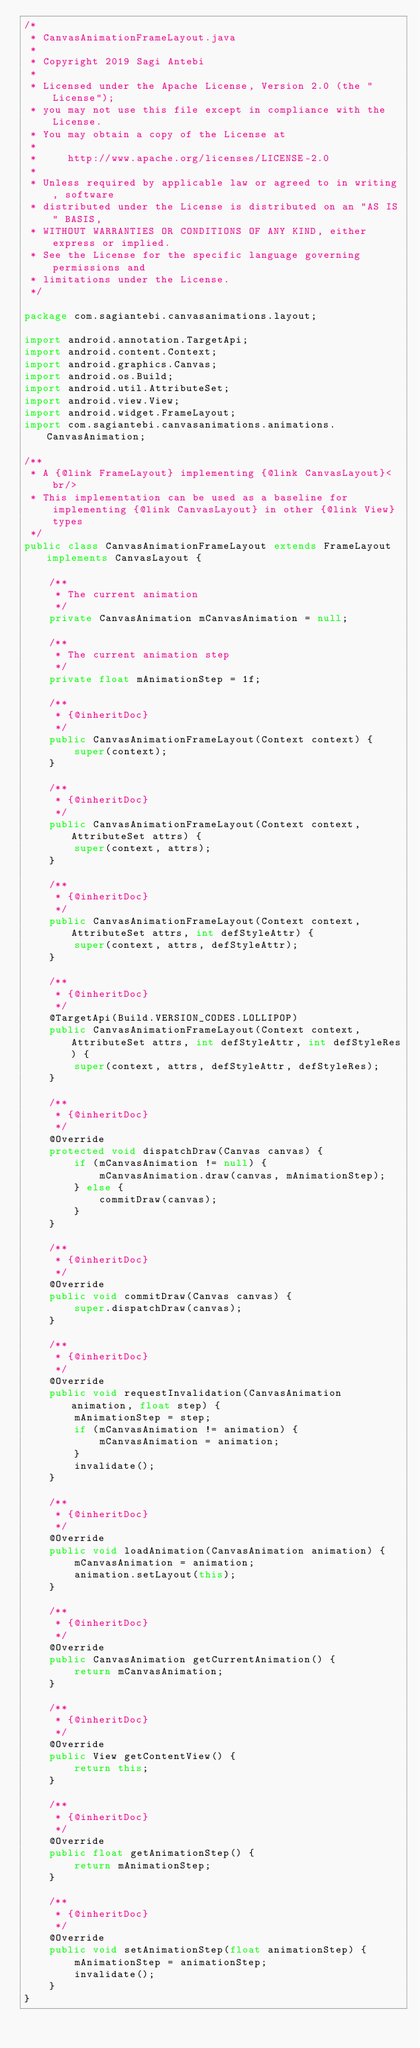Convert code to text. <code><loc_0><loc_0><loc_500><loc_500><_Java_>/*
 * CanvasAnimationFrameLayout.java
 *
 * Copyright 2019 Sagi Antebi
 *
 * Licensed under the Apache License, Version 2.0 (the "License");
 * you may not use this file except in compliance with the License.
 * You may obtain a copy of the License at
 *
 *     http://www.apache.org/licenses/LICENSE-2.0
 *
 * Unless required by applicable law or agreed to in writing, software
 * distributed under the License is distributed on an "AS IS" BASIS,
 * WITHOUT WARRANTIES OR CONDITIONS OF ANY KIND, either express or implied.
 * See the License for the specific language governing permissions and
 * limitations under the License.
 */

package com.sagiantebi.canvasanimations.layout;

import android.annotation.TargetApi;
import android.content.Context;
import android.graphics.Canvas;
import android.os.Build;
import android.util.AttributeSet;
import android.view.View;
import android.widget.FrameLayout;
import com.sagiantebi.canvasanimations.animations.CanvasAnimation;

/**
 * A {@link FrameLayout} implementing {@link CanvasLayout}<br/>
 * This implementation can be used as a baseline for implementing {@link CanvasLayout} in other {@link View} types
 */
public class CanvasAnimationFrameLayout extends FrameLayout implements CanvasLayout {

    /**
     * The current animation
     */
    private CanvasAnimation mCanvasAnimation = null;

    /**
     * The current animation step
     */
    private float mAnimationStep = 1f;

    /**
     * {@inheritDoc}
     */
    public CanvasAnimationFrameLayout(Context context) {
        super(context);
    }

    /**
     * {@inheritDoc}
     */
    public CanvasAnimationFrameLayout(Context context, AttributeSet attrs) {
        super(context, attrs);
    }

    /**
     * {@inheritDoc}
     */
    public CanvasAnimationFrameLayout(Context context, AttributeSet attrs, int defStyleAttr) {
        super(context, attrs, defStyleAttr);
    }

    /**
     * {@inheritDoc}
     */
    @TargetApi(Build.VERSION_CODES.LOLLIPOP)
    public CanvasAnimationFrameLayout(Context context, AttributeSet attrs, int defStyleAttr, int defStyleRes) {
        super(context, attrs, defStyleAttr, defStyleRes);
    }

    /**
     * {@inheritDoc}
     */
    @Override
    protected void dispatchDraw(Canvas canvas) {
        if (mCanvasAnimation != null) {
            mCanvasAnimation.draw(canvas, mAnimationStep);
        } else {
            commitDraw(canvas);
        }
    }

    /**
     * {@inheritDoc}
     */
    @Override
    public void commitDraw(Canvas canvas) {
        super.dispatchDraw(canvas);
    }

    /**
     * {@inheritDoc}
     */
    @Override
    public void requestInvalidation(CanvasAnimation animation, float step) {
        mAnimationStep = step;
        if (mCanvasAnimation != animation) {
            mCanvasAnimation = animation;
        }
        invalidate();
    }

    /**
     * {@inheritDoc}
     */
    @Override
    public void loadAnimation(CanvasAnimation animation) {
        mCanvasAnimation = animation;
        animation.setLayout(this);
    }

    /**
     * {@inheritDoc}
     */
    @Override
    public CanvasAnimation getCurrentAnimation() {
        return mCanvasAnimation;
    }

    /**
     * {@inheritDoc}
     */
    @Override
    public View getContentView() {
        return this;
    }

    /**
     * {@inheritDoc}
     */
    @Override
    public float getAnimationStep() {
        return mAnimationStep;
    }

    /**
     * {@inheritDoc}
     */
    @Override
    public void setAnimationStep(float animationStep) {
        mAnimationStep = animationStep;
        invalidate();
    }
}
</code> 